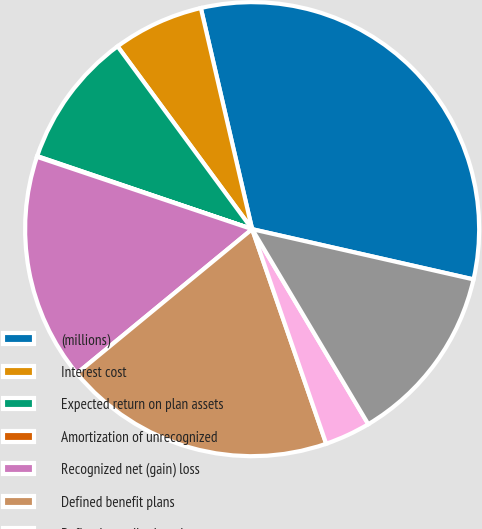Convert chart to OTSL. <chart><loc_0><loc_0><loc_500><loc_500><pie_chart><fcel>(millions)<fcel>Interest cost<fcel>Expected return on plan assets<fcel>Amortization of unrecognized<fcel>Recognized net (gain) loss<fcel>Defined benefit plans<fcel>Defined contribution plans<fcel>Total<nl><fcel>32.18%<fcel>6.47%<fcel>9.69%<fcel>0.05%<fcel>16.12%<fcel>19.33%<fcel>3.26%<fcel>12.9%<nl></chart> 